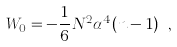<formula> <loc_0><loc_0><loc_500><loc_500>W _ { 0 } = - \frac { 1 } { 6 } N ^ { 2 } \alpha ^ { 4 } ( n - 1 ) \ ,</formula> 